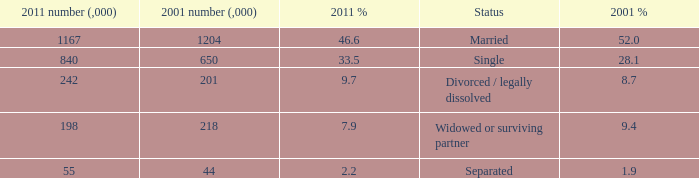How many 2011 % is 7.9? 1.0. 